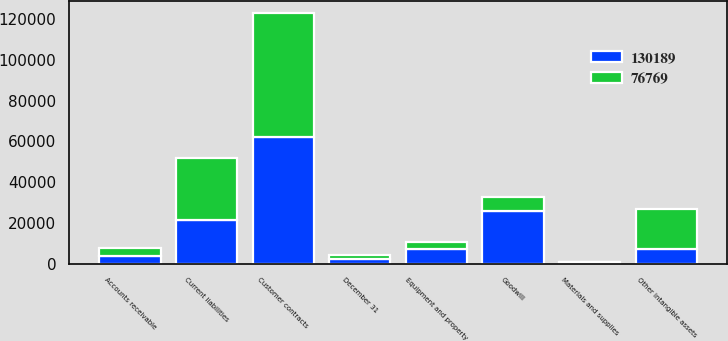Convert chart. <chart><loc_0><loc_0><loc_500><loc_500><stacked_bar_chart><ecel><fcel>December 31<fcel>Accounts receivable<fcel>Materials and supplies<fcel>Equipment and property<fcel>Goodwill<fcel>Customer contracts<fcel>Other intangible assets<fcel>Current liabilities<nl><fcel>130189<fcel>2018<fcel>3558<fcel>556<fcel>7374<fcel>25605<fcel>62228<fcel>6936<fcel>21536<nl><fcel>76769<fcel>2017<fcel>3836<fcel>312<fcel>3027<fcel>6936<fcel>60695<fcel>20086<fcel>30344<nl></chart> 